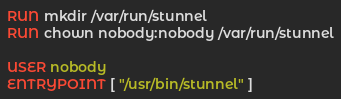Convert code to text. <code><loc_0><loc_0><loc_500><loc_500><_Dockerfile_>RUN mkdir /var/run/stunnel
RUN chown nobody:nobody /var/run/stunnel

USER nobody
ENTRYPOINT [ "/usr/bin/stunnel" ]
</code> 